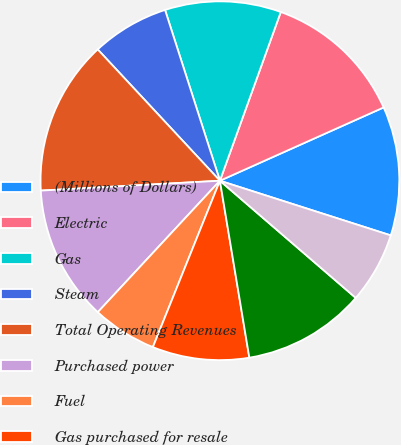Convert chart to OTSL. <chart><loc_0><loc_0><loc_500><loc_500><pie_chart><fcel>(Millions of Dollars)<fcel>Electric<fcel>Gas<fcel>Steam<fcel>Total Operating Revenues<fcel>Purchased power<fcel>Fuel<fcel>Gas purchased for resale<fcel>Other operations and<fcel>Depreciation and amortization<nl><fcel>11.63%<fcel>12.79%<fcel>10.46%<fcel>6.98%<fcel>13.95%<fcel>12.21%<fcel>5.82%<fcel>8.72%<fcel>11.05%<fcel>6.4%<nl></chart> 